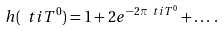<formula> <loc_0><loc_0><loc_500><loc_500>h ( \ t i { T } ^ { 0 } ) = 1 + 2 e ^ { - 2 \pi \ t i { T } ^ { 0 } } + \dots \, .</formula> 